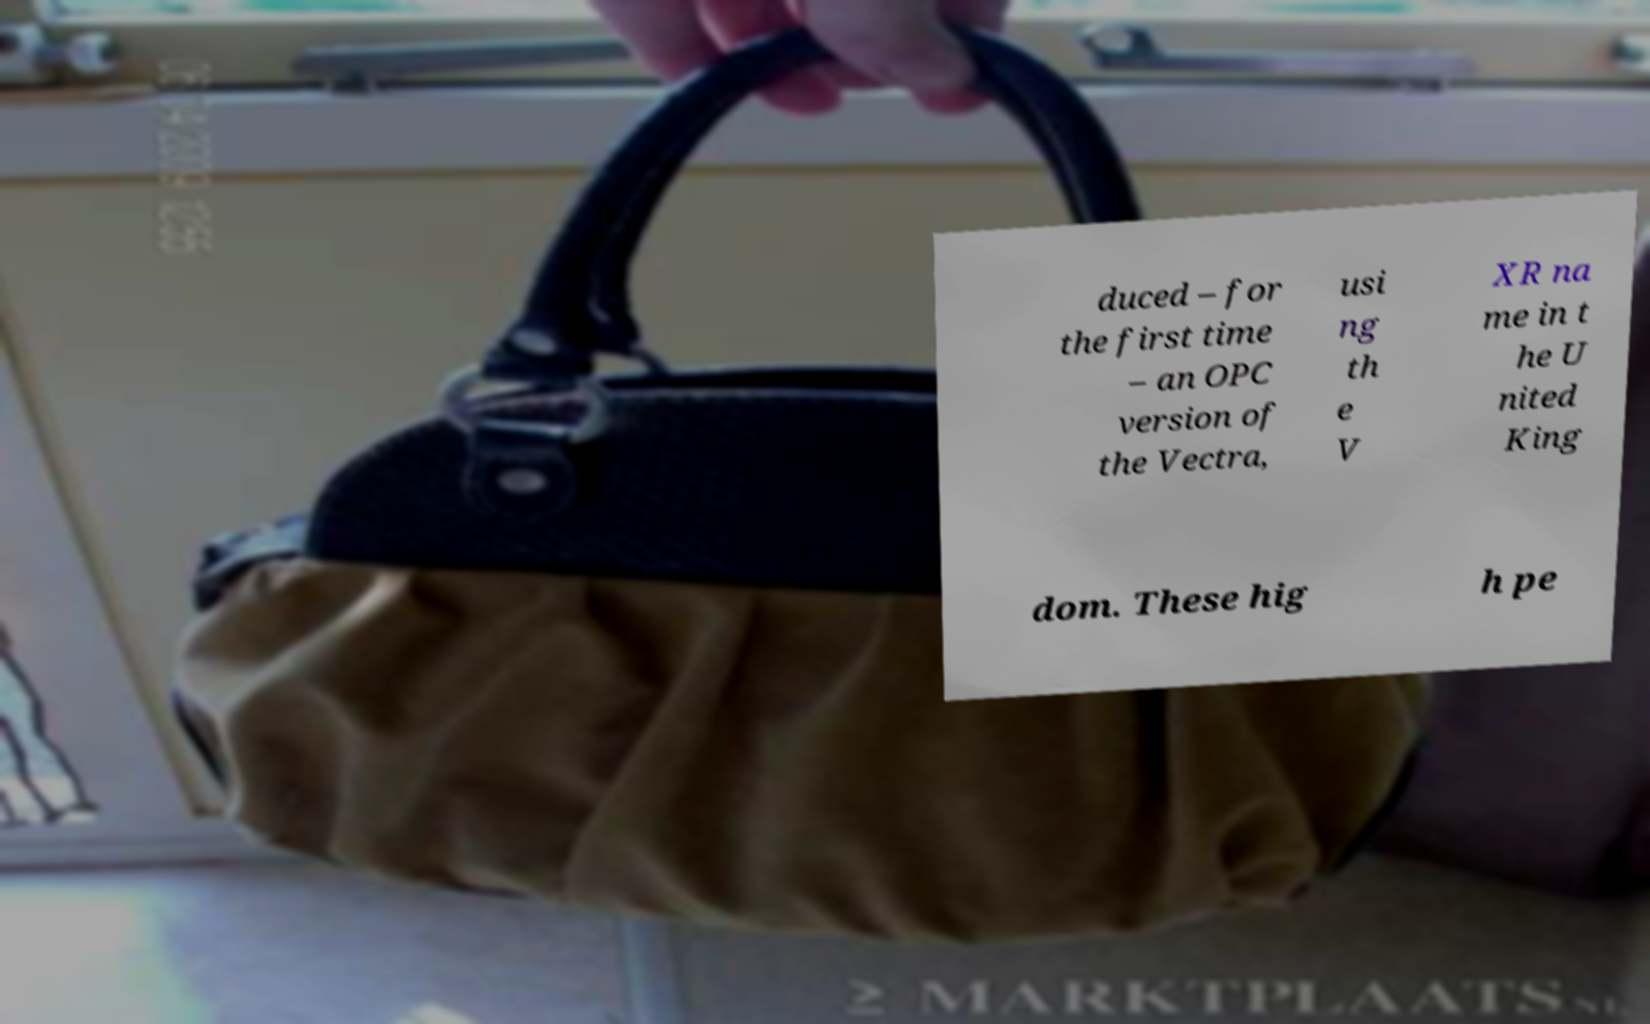Can you read and provide the text displayed in the image?This photo seems to have some interesting text. Can you extract and type it out for me? duced – for the first time – an OPC version of the Vectra, usi ng th e V XR na me in t he U nited King dom. These hig h pe 